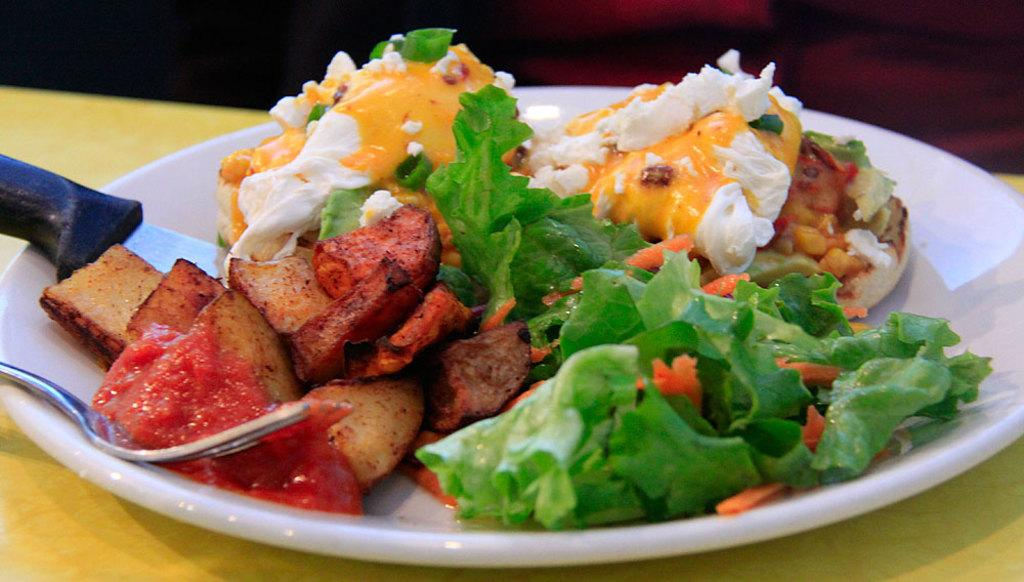What is on the plate that is visible in the image? There is food on a plate in the image. What utensils are present on the plate? There is a knife and a fork on the plate. Where is the plate located in the image? The plate is on a surface in the image. What type of minister is present in the image? There is no minister present in the image; it features a plate with food and utensils. What is the coefficient of friction between the plate and the surface in the image? The coefficient of friction cannot be determined from the image, as it is a photograph and not a scientific experiment. 